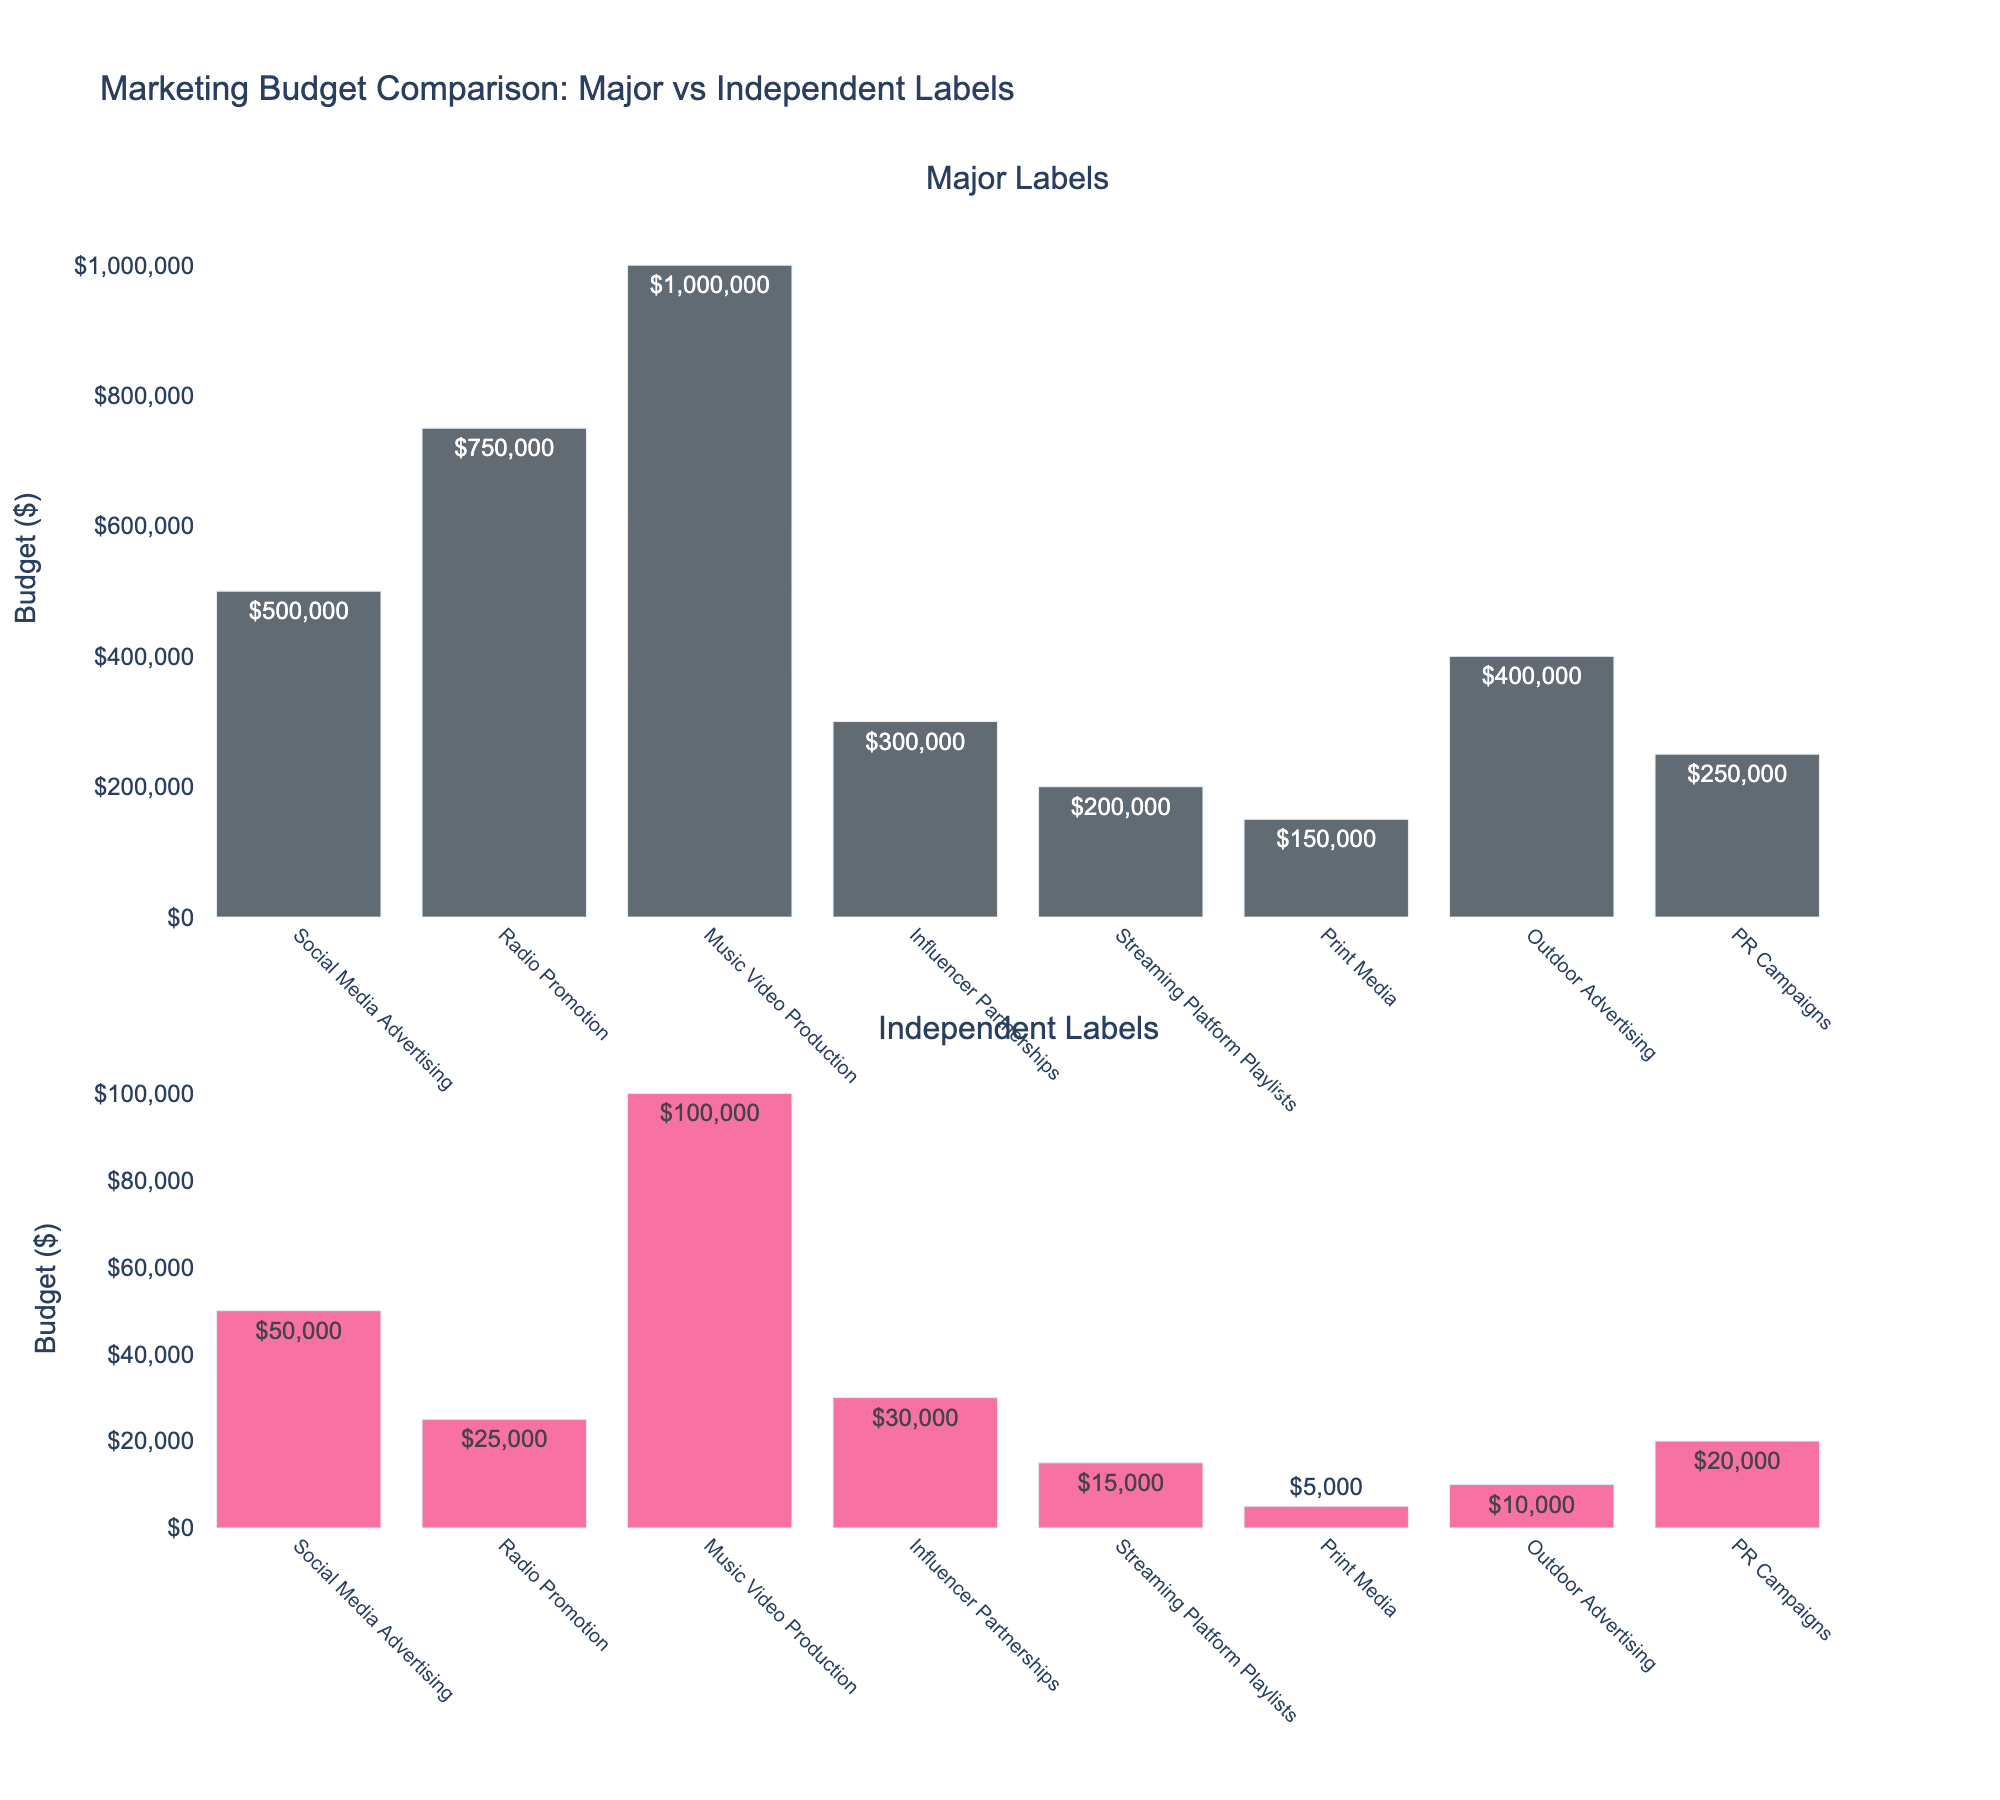What is the total marketing budget for Major Labels on Social Media Advertising and Radio Promotion? Add the budgets for Social Media Advertising ($500,000) and Radio Promotion ($750,000) to get the total budget.
Answer: $1,250,000 Which promotional channel has the highest budget for Independent Labels? Look for the highest bar in the Independent Labels subplot. The highest bar is for Music Video Production with a budget of $100,000.
Answer: Music Video Production How much more do Major Labels spend on PR Campaigns compared to Independent Labels? Subtract the PR Campaigns budget for Independent Labels ($20,000) from the PR Campaigns budget for Major Labels ($250,000).
Answer: $230,000 What is the average budget of Major Labels across all channels? Sum the budgets for all channels for Major Labels and divide by the number of channels (8). The total budget is $3,350,000, so the average is $3,350,000 / 8.
Answer: $418,750 Which channel has the smallest difference in budget between Major Labels and Independent Labels? Calculate the difference for each channel and find the smallest. The smallest difference is for Print Media ($150,000 - $5,000 = $145,000).
Answer: Print Media What is the combined budget for Major Labels on Influencer Partnerships and Streaming Platform Playlists? Add the budgets for Influencer Partnerships ($300,000) and Streaming Platform Playlists ($200,000).
Answer: $500,000 Which label spends more on Outdoor Advertising and by how much? Compare the Outdoor Advertising budgets: Major Labels ($400,000) vs Independent Labels ($10,000). The difference is $400,000 - $10,000.
Answer: Major Labels, $390,000 What proportion of the Independent Labels' budget for PR Campaigns is compared to their budget for Social Media Advertising? Divide the PR Campaigns budget ($20,000) by the Social Media Advertising budget ($50,000). Proportion is $20,000 / $50,000.
Answer: 0.4 Which label allocates a higher percentage of its total marketing budget to Radio Promotion? Calculate the proportion for each: Major Labels - $750,000/$3,350,000; Independent Labels - $25,000/$250,000. Compare the percentages.
Answer: Independent Labels How many times larger is the Major Labels' budget for Music Video Production compared to Independent Labels? Divide the Music Video Production budget of Major Labels ($1,000,000) by that of Independent Labels ($100,000).
Answer: 10 